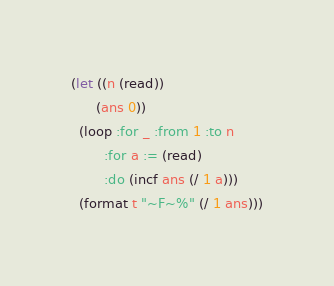<code> <loc_0><loc_0><loc_500><loc_500><_Lisp_>(let ((n (read))
      (ans 0))
  (loop :for _ :from 1 :to n
        :for a := (read)
        :do (incf ans (/ 1 a)))
  (format t "~F~%" (/ 1 ans)))
</code> 